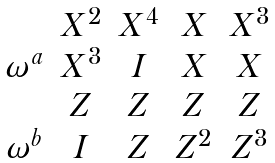<formula> <loc_0><loc_0><loc_500><loc_500>\begin{array} { c c c c c } \ & X ^ { 2 } & X ^ { 4 } & X & X ^ { 3 } \\ \omega ^ { a } & X ^ { 3 } & I & X & X \\ \ & Z & Z & Z & Z \\ \omega ^ { b } & I & Z & Z ^ { 2 } & Z ^ { 3 } \end{array}</formula> 